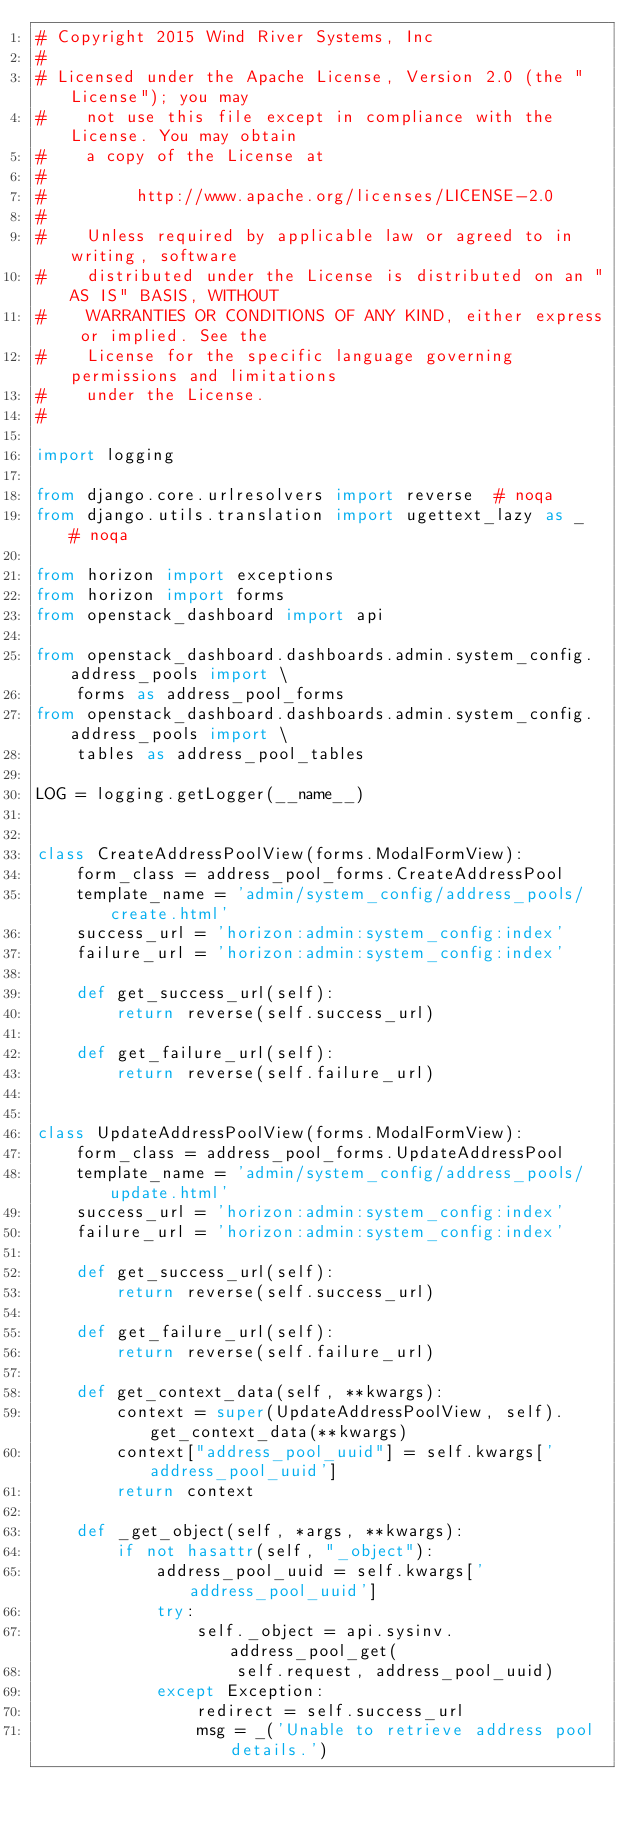Convert code to text. <code><loc_0><loc_0><loc_500><loc_500><_Python_># Copyright 2015 Wind River Systems, Inc
#
# Licensed under the Apache License, Version 2.0 (the "License"); you may
#    not use this file except in compliance with the License. You may obtain
#    a copy of the License at
#
#         http://www.apache.org/licenses/LICENSE-2.0
#
#    Unless required by applicable law or agreed to in writing, software
#    distributed under the License is distributed on an "AS IS" BASIS, WITHOUT
#    WARRANTIES OR CONDITIONS OF ANY KIND, either express or implied. See the
#    License for the specific language governing permissions and limitations
#    under the License.
#

import logging

from django.core.urlresolvers import reverse  # noqa
from django.utils.translation import ugettext_lazy as _  # noqa

from horizon import exceptions
from horizon import forms
from openstack_dashboard import api

from openstack_dashboard.dashboards.admin.system_config.address_pools import \
    forms as address_pool_forms
from openstack_dashboard.dashboards.admin.system_config.address_pools import \
    tables as address_pool_tables

LOG = logging.getLogger(__name__)


class CreateAddressPoolView(forms.ModalFormView):
    form_class = address_pool_forms.CreateAddressPool
    template_name = 'admin/system_config/address_pools/create.html'
    success_url = 'horizon:admin:system_config:index'
    failure_url = 'horizon:admin:system_config:index'

    def get_success_url(self):
        return reverse(self.success_url)

    def get_failure_url(self):
        return reverse(self.failure_url)


class UpdateAddressPoolView(forms.ModalFormView):
    form_class = address_pool_forms.UpdateAddressPool
    template_name = 'admin/system_config/address_pools/update.html'
    success_url = 'horizon:admin:system_config:index'
    failure_url = 'horizon:admin:system_config:index'

    def get_success_url(self):
        return reverse(self.success_url)

    def get_failure_url(self):
        return reverse(self.failure_url)

    def get_context_data(self, **kwargs):
        context = super(UpdateAddressPoolView, self).get_context_data(**kwargs)
        context["address_pool_uuid"] = self.kwargs['address_pool_uuid']
        return context

    def _get_object(self, *args, **kwargs):
        if not hasattr(self, "_object"):
            address_pool_uuid = self.kwargs['address_pool_uuid']
            try:
                self._object = api.sysinv.address_pool_get(
                    self.request, address_pool_uuid)
            except Exception:
                redirect = self.success_url
                msg = _('Unable to retrieve address pool details.')</code> 